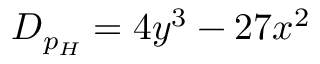Convert formula to latex. <formula><loc_0><loc_0><loc_500><loc_500>D _ { p _ { H } } = 4 y ^ { 3 } - 2 7 x ^ { 2 }</formula> 